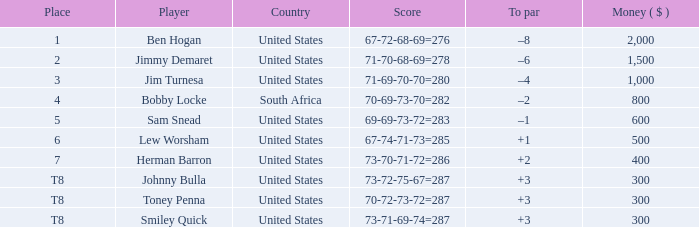What is the currency of the player in position 5? 600.0. 